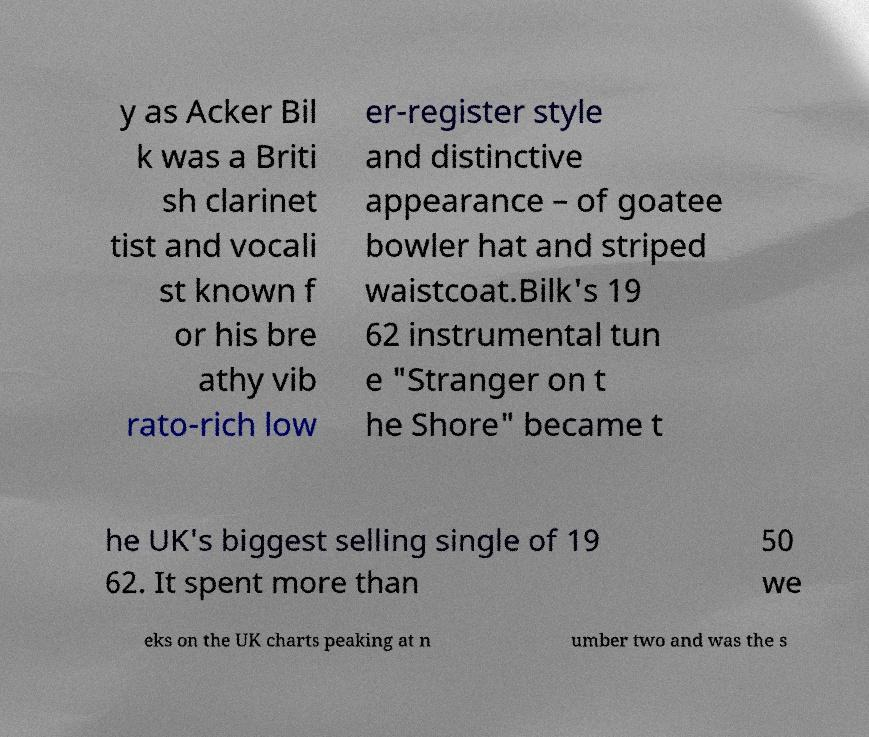Please read and relay the text visible in this image. What does it say? y as Acker Bil k was a Briti sh clarinet tist and vocali st known f or his bre athy vib rato-rich low er-register style and distinctive appearance – of goatee bowler hat and striped waistcoat.Bilk's 19 62 instrumental tun e "Stranger on t he Shore" became t he UK's biggest selling single of 19 62. It spent more than 50 we eks on the UK charts peaking at n umber two and was the s 